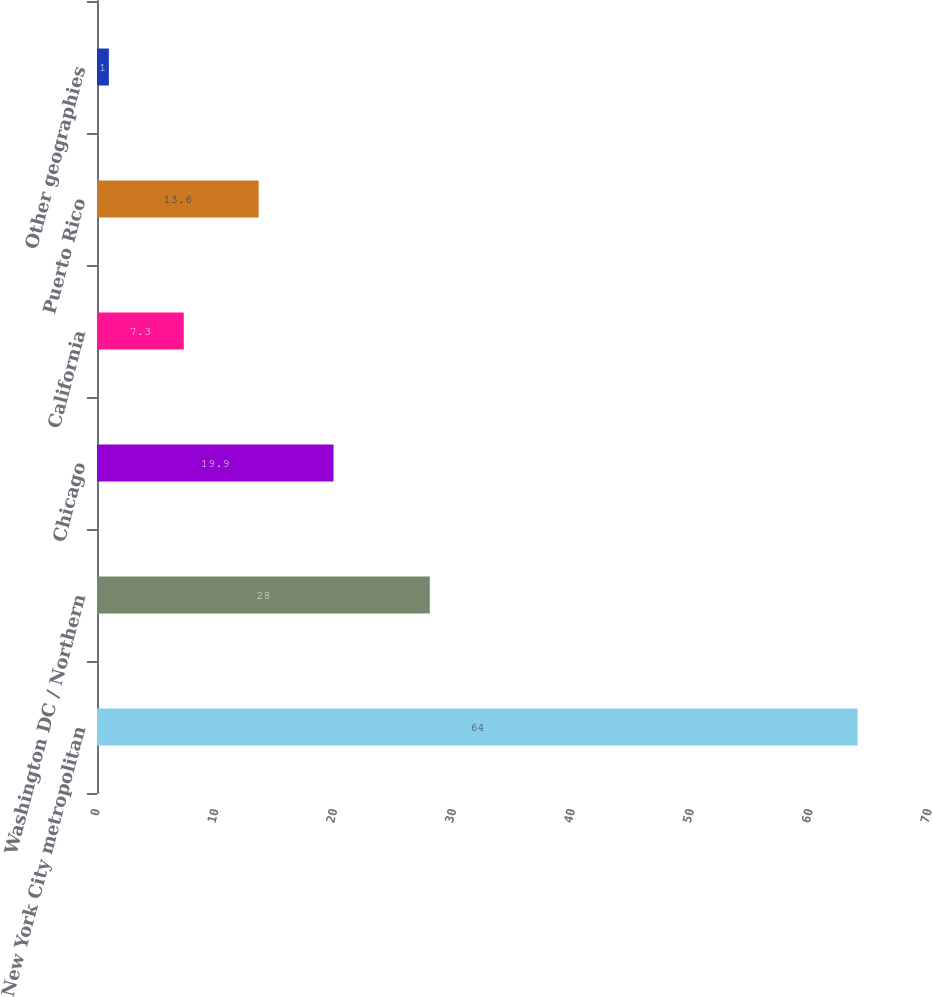<chart> <loc_0><loc_0><loc_500><loc_500><bar_chart><fcel>New York City metropolitan<fcel>Washington DC / Northern<fcel>Chicago<fcel>California<fcel>Puerto Rico<fcel>Other geographies<nl><fcel>64<fcel>28<fcel>19.9<fcel>7.3<fcel>13.6<fcel>1<nl></chart> 